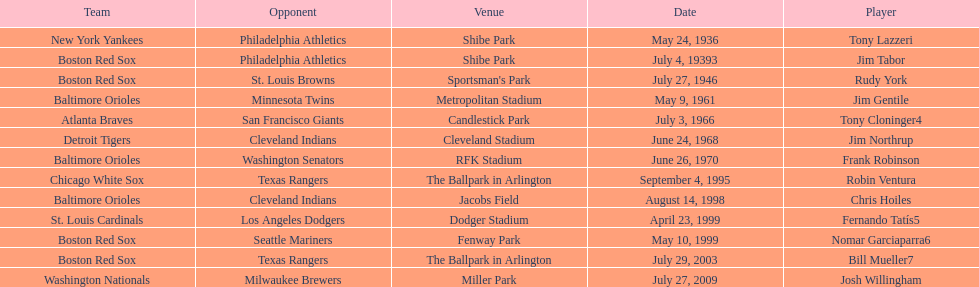What is the number of times a boston red sox player has had two grand slams in one game? 4. 